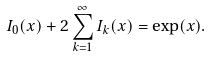Convert formula to latex. <formula><loc_0><loc_0><loc_500><loc_500>I _ { 0 } ( x ) + 2 \sum _ { k = 1 } ^ { \infty } I _ { k } ( x ) = \exp ( x ) .</formula> 